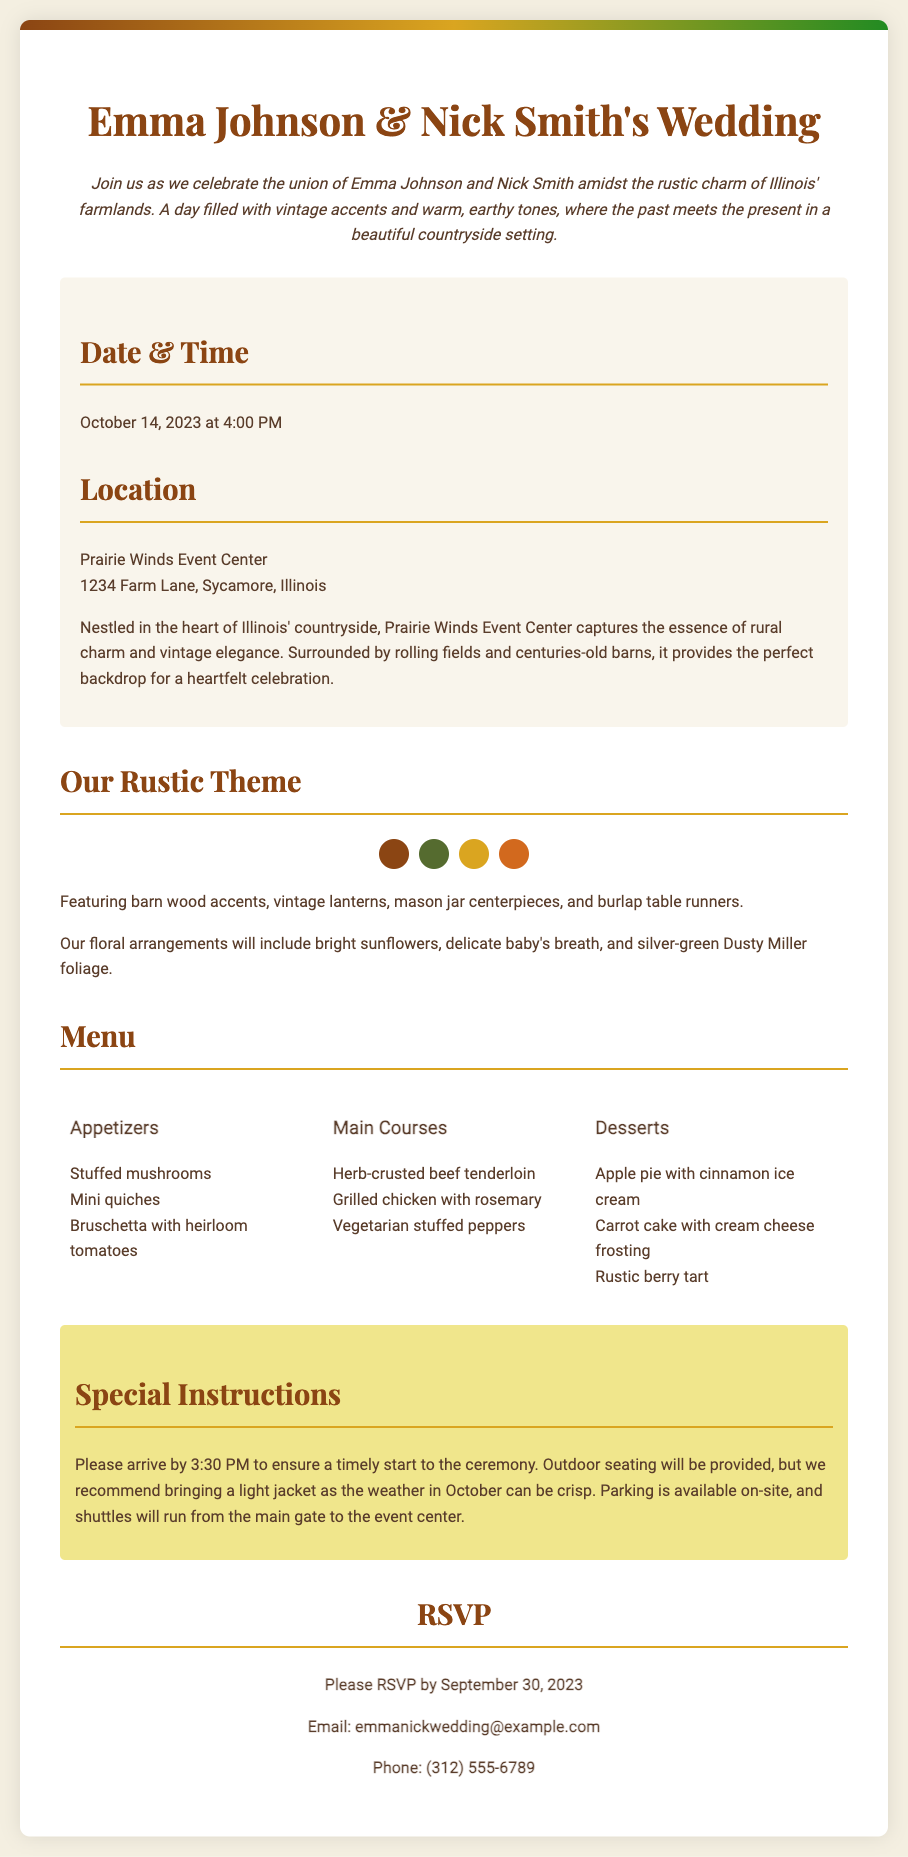What is the date of the wedding? The date is explicitly mentioned in the document as "October 14, 2023".
Answer: October 14, 2023 What time does the wedding ceremony start? The start time for the ceremony is stated in the details section of the invitation.
Answer: 4:00 PM Where is the wedding taking place? The location is specified in the document as "Prairie Winds Event Center, 1234 Farm Lane, Sycamore, Illinois".
Answer: Prairie Winds Event Center What type of floral arrangements will be used? The document describes the floral arrangements that will include specific types of flowers.
Answer: Bright sunflowers, delicate baby's breath, and Dusty Miller How many main course options are listed? The document lists three main course options in the menu section.
Answer: Three What should guests bring according to the special instructions? The special instructions recommend that guests should bring something due to the weather conditions.
Answer: Light jacket What is the RSVP deadline? The deadline for RSVPs is specified in the contact section of the invitation.
Answer: September 30, 2023 What is the email address for RSVPs? The email address for RSVPs is provided in the contact information section of the document.
Answer: emmanickwedding@example.com How many appetizers are listed? The document counts the number of appetizers provided in the menu section.
Answer: Three 